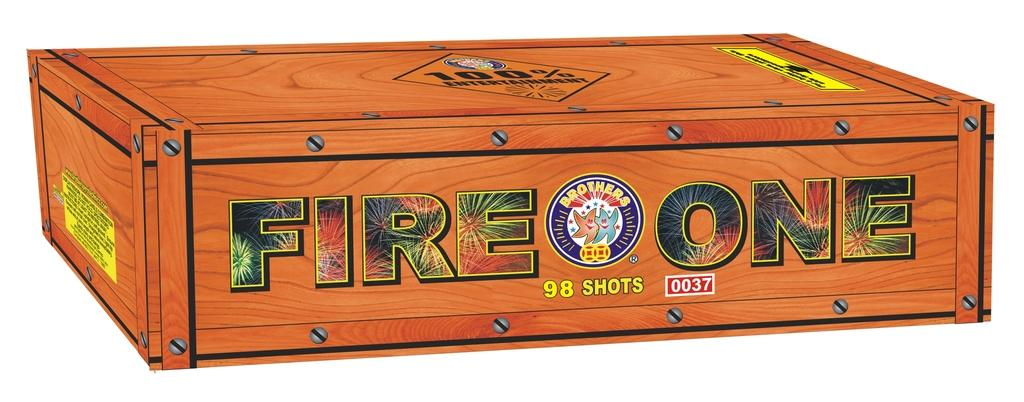What type of image is being described? The image is animated. What object can be seen in the image? There is a wooden box in the image. What are the nails used for in the image? The nails are used to fix the box. Is there any text or label on the box? Yes, there is a name on the box. What color is the shirt worn by the wall in the image? There is no wall or shirt present in the image; it features an animated wooden box with nails and a name. 